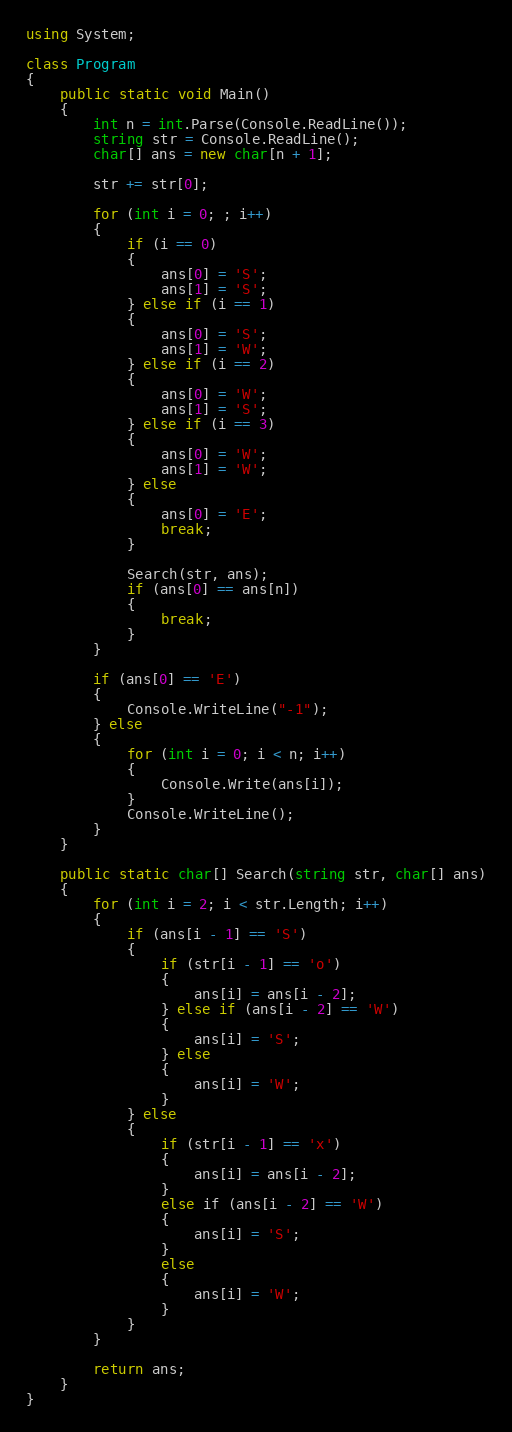<code> <loc_0><loc_0><loc_500><loc_500><_C#_>using System;

class Program
{
    public static void Main()
    {
        int n = int.Parse(Console.ReadLine());
        string str = Console.ReadLine();
        char[] ans = new char[n + 1];

        str += str[0];

        for (int i = 0; ; i++)
        {
            if (i == 0)
            {
                ans[0] = 'S';
                ans[1] = 'S';
            } else if (i == 1)
            {
                ans[0] = 'S';
                ans[1] = 'W';
            } else if (i == 2)
            {
                ans[0] = 'W';
                ans[1] = 'S';
            } else if (i == 3)
            {
                ans[0] = 'W';
                ans[1] = 'W';
            } else
            {
                ans[0] = 'E';
                break;
            }

            Search(str, ans);
            if (ans[0] == ans[n])
            {
                break;
            }
        }

        if (ans[0] == 'E')
        {
            Console.WriteLine("-1");
        } else
        {
            for (int i = 0; i < n; i++)
            {
                Console.Write(ans[i]);
            }
            Console.WriteLine();
        }
    }

    public static char[] Search(string str, char[] ans)
    {
        for (int i = 2; i < str.Length; i++)
        {
            if (ans[i - 1] == 'S')
            {
                if (str[i - 1] == 'o')
                {
                    ans[i] = ans[i - 2];
                } else if (ans[i - 2] == 'W')
                {
                    ans[i] = 'S';
                } else
                {
                    ans[i] = 'W';
                }
            } else
            {
                if (str[i - 1] == 'x')
                {
                    ans[i] = ans[i - 2];
                }
                else if (ans[i - 2] == 'W')
                {
                    ans[i] = 'S';
                }
                else
                {
                    ans[i] = 'W';
                }
            }
        }

        return ans;
    }
}</code> 